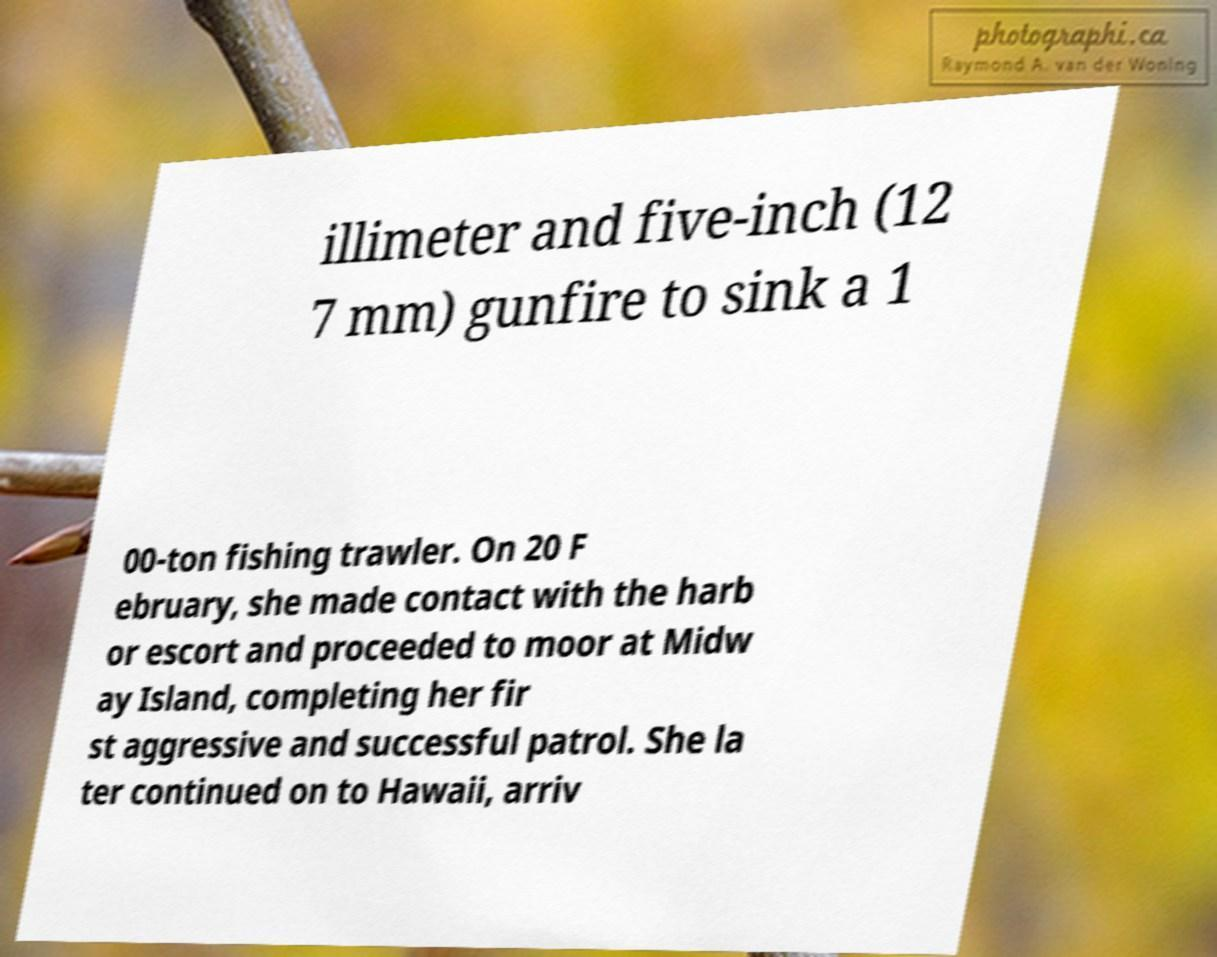Could you assist in decoding the text presented in this image and type it out clearly? illimeter and five-inch (12 7 mm) gunfire to sink a 1 00-ton fishing trawler. On 20 F ebruary, she made contact with the harb or escort and proceeded to moor at Midw ay Island, completing her fir st aggressive and successful patrol. She la ter continued on to Hawaii, arriv 